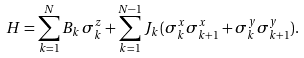Convert formula to latex. <formula><loc_0><loc_0><loc_500><loc_500>H = \sum _ { k = 1 } ^ { N } B _ { k } \, \sigma _ { k } ^ { z } + \sum _ { k = 1 } ^ { N - 1 } J _ { k } \, ( \sigma ^ { x } _ { k } \sigma ^ { x } _ { k + 1 } + \sigma ^ { y } _ { k } \sigma ^ { y } _ { k + 1 } ) .</formula> 